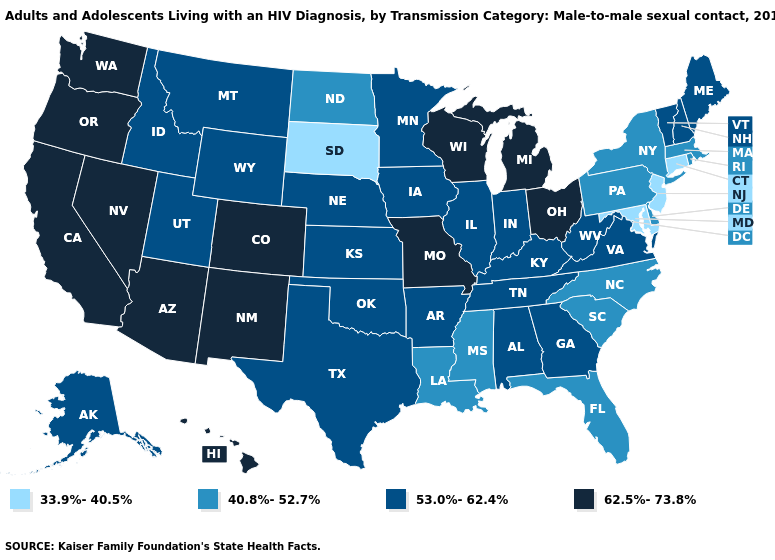Among the states that border Vermont , which have the lowest value?
Give a very brief answer. Massachusetts, New York. Name the states that have a value in the range 40.8%-52.7%?
Be succinct. Delaware, Florida, Louisiana, Massachusetts, Mississippi, New York, North Carolina, North Dakota, Pennsylvania, Rhode Island, South Carolina. How many symbols are there in the legend?
Short answer required. 4. Which states have the highest value in the USA?
Write a very short answer. Arizona, California, Colorado, Hawaii, Michigan, Missouri, Nevada, New Mexico, Ohio, Oregon, Washington, Wisconsin. What is the value of West Virginia?
Answer briefly. 53.0%-62.4%. What is the value of Hawaii?
Give a very brief answer. 62.5%-73.8%. Which states have the lowest value in the USA?
Short answer required. Connecticut, Maryland, New Jersey, South Dakota. What is the value of New Hampshire?
Answer briefly. 53.0%-62.4%. Name the states that have a value in the range 33.9%-40.5%?
Answer briefly. Connecticut, Maryland, New Jersey, South Dakota. Name the states that have a value in the range 33.9%-40.5%?
Be succinct. Connecticut, Maryland, New Jersey, South Dakota. Name the states that have a value in the range 53.0%-62.4%?
Be succinct. Alabama, Alaska, Arkansas, Georgia, Idaho, Illinois, Indiana, Iowa, Kansas, Kentucky, Maine, Minnesota, Montana, Nebraska, New Hampshire, Oklahoma, Tennessee, Texas, Utah, Vermont, Virginia, West Virginia, Wyoming. Which states hav the highest value in the South?
Be succinct. Alabama, Arkansas, Georgia, Kentucky, Oklahoma, Tennessee, Texas, Virginia, West Virginia. Name the states that have a value in the range 40.8%-52.7%?
Short answer required. Delaware, Florida, Louisiana, Massachusetts, Mississippi, New York, North Carolina, North Dakota, Pennsylvania, Rhode Island, South Carolina. How many symbols are there in the legend?
Short answer required. 4. 